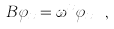<formula> <loc_0><loc_0><loc_500><loc_500>B \varphi _ { x } = \omega ^ { x } \varphi _ { x } \ ,</formula> 